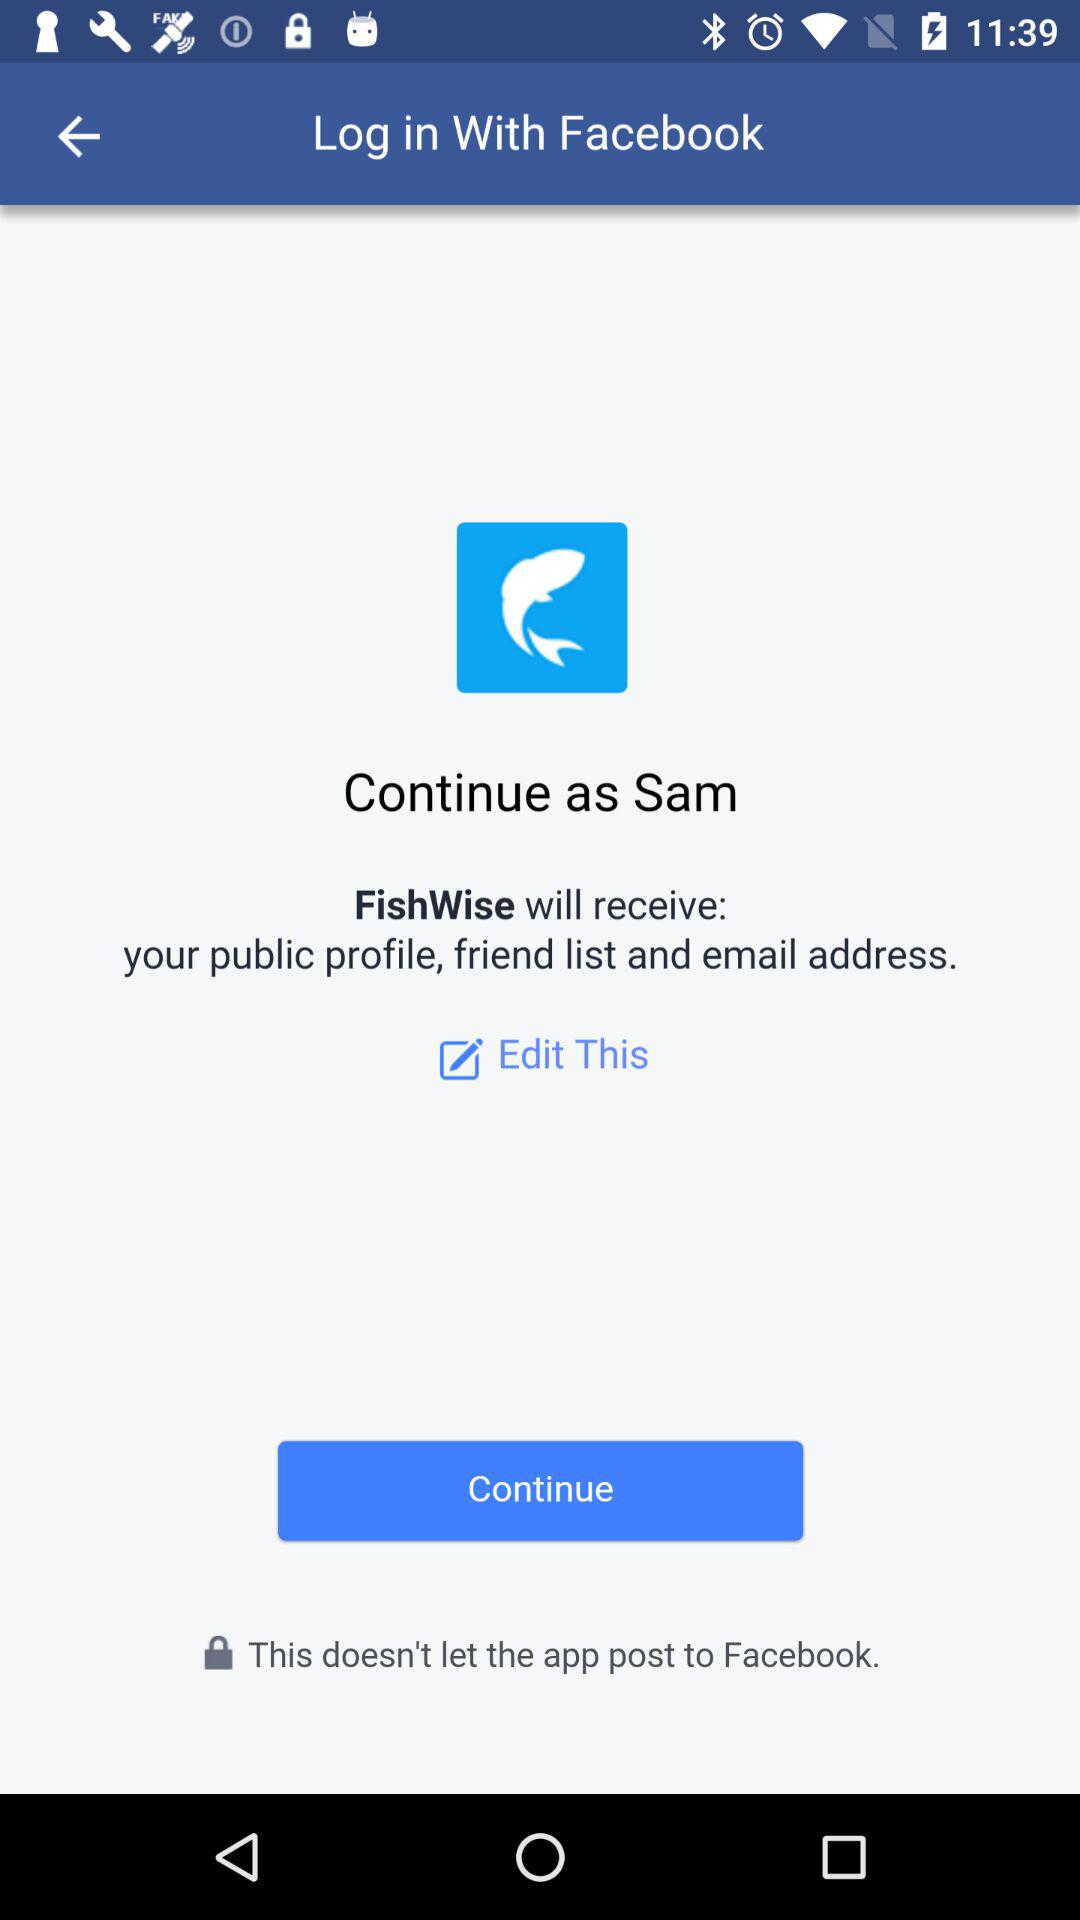Which information will "FishWise" receive? "FishWise" will receive the public profile, friend list and email address. 